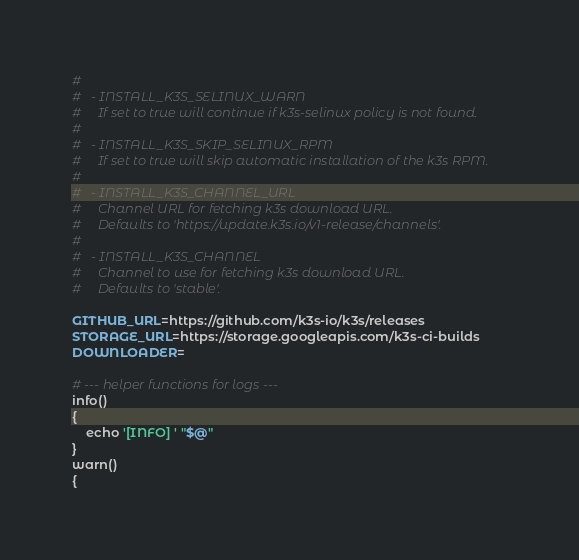Convert code to text. <code><loc_0><loc_0><loc_500><loc_500><_Bash_>#
#   - INSTALL_K3S_SELINUX_WARN
#     If set to true will continue if k3s-selinux policy is not found.
#
#   - INSTALL_K3S_SKIP_SELINUX_RPM
#     If set to true will skip automatic installation of the k3s RPM.
#
#   - INSTALL_K3S_CHANNEL_URL
#     Channel URL for fetching k3s download URL.
#     Defaults to 'https://update.k3s.io/v1-release/channels'.
#
#   - INSTALL_K3S_CHANNEL
#     Channel to use for fetching k3s download URL.
#     Defaults to 'stable'.

GITHUB_URL=https://github.com/k3s-io/k3s/releases
STORAGE_URL=https://storage.googleapis.com/k3s-ci-builds
DOWNLOADER=

# --- helper functions for logs ---
info()
{
    echo '[INFO] ' "$@"
}
warn()
{</code> 